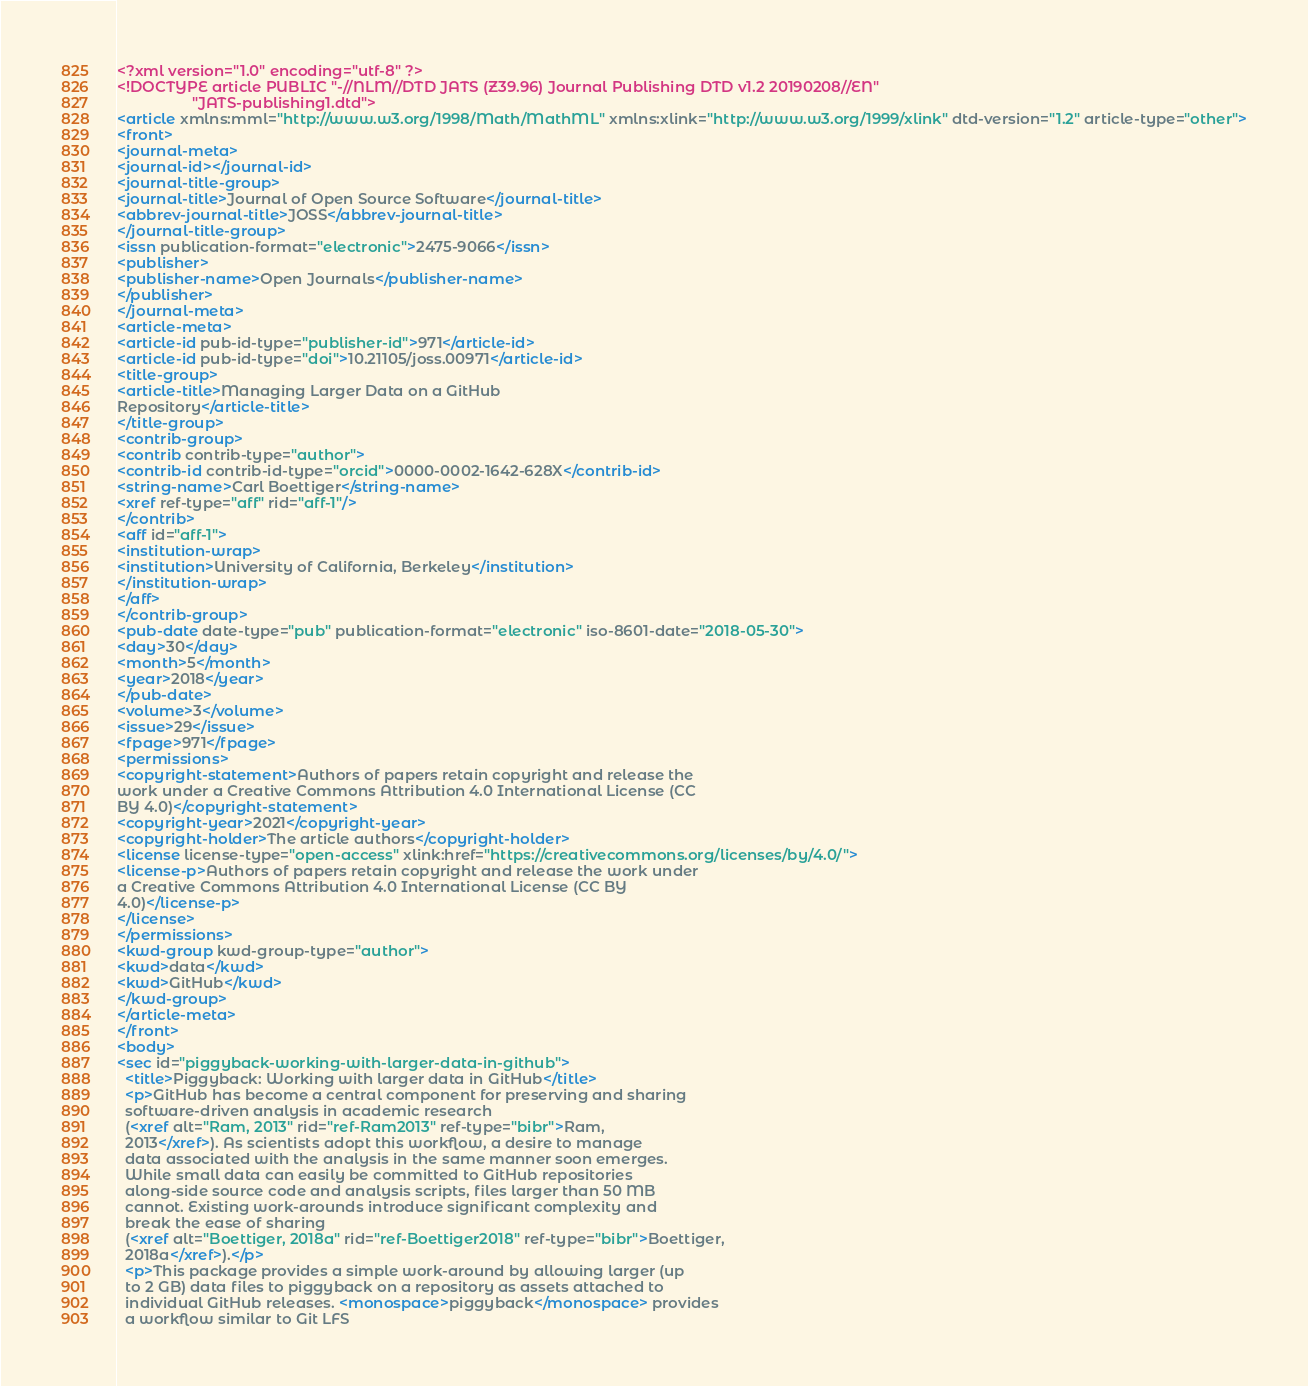Convert code to text. <code><loc_0><loc_0><loc_500><loc_500><_XML_><?xml version="1.0" encoding="utf-8" ?>
<!DOCTYPE article PUBLIC "-//NLM//DTD JATS (Z39.96) Journal Publishing DTD v1.2 20190208//EN"
                  "JATS-publishing1.dtd">
<article xmlns:mml="http://www.w3.org/1998/Math/MathML" xmlns:xlink="http://www.w3.org/1999/xlink" dtd-version="1.2" article-type="other">
<front>
<journal-meta>
<journal-id></journal-id>
<journal-title-group>
<journal-title>Journal of Open Source Software</journal-title>
<abbrev-journal-title>JOSS</abbrev-journal-title>
</journal-title-group>
<issn publication-format="electronic">2475-9066</issn>
<publisher>
<publisher-name>Open Journals</publisher-name>
</publisher>
</journal-meta>
<article-meta>
<article-id pub-id-type="publisher-id">971</article-id>
<article-id pub-id-type="doi">10.21105/joss.00971</article-id>
<title-group>
<article-title>Managing Larger Data on a GitHub
Repository</article-title>
</title-group>
<contrib-group>
<contrib contrib-type="author">
<contrib-id contrib-id-type="orcid">0000-0002-1642-628X</contrib-id>
<string-name>Carl Boettiger</string-name>
<xref ref-type="aff" rid="aff-1"/>
</contrib>
<aff id="aff-1">
<institution-wrap>
<institution>University of California, Berkeley</institution>
</institution-wrap>
</aff>
</contrib-group>
<pub-date date-type="pub" publication-format="electronic" iso-8601-date="2018-05-30">
<day>30</day>
<month>5</month>
<year>2018</year>
</pub-date>
<volume>3</volume>
<issue>29</issue>
<fpage>971</fpage>
<permissions>
<copyright-statement>Authors of papers retain copyright and release the
work under a Creative Commons Attribution 4.0 International License (CC
BY 4.0)</copyright-statement>
<copyright-year>2021</copyright-year>
<copyright-holder>The article authors</copyright-holder>
<license license-type="open-access" xlink:href="https://creativecommons.org/licenses/by/4.0/">
<license-p>Authors of papers retain copyright and release the work under
a Creative Commons Attribution 4.0 International License (CC BY
4.0)</license-p>
</license>
</permissions>
<kwd-group kwd-group-type="author">
<kwd>data</kwd>
<kwd>GitHub</kwd>
</kwd-group>
</article-meta>
</front>
<body>
<sec id="piggyback-working-with-larger-data-in-github">
  <title>Piggyback: Working with larger data in GitHub</title>
  <p>GitHub has become a central component for preserving and sharing
  software-driven analysis in academic research
  (<xref alt="Ram, 2013" rid="ref-Ram2013" ref-type="bibr">Ram,
  2013</xref>). As scientists adopt this workflow, a desire to manage
  data associated with the analysis in the same manner soon emerges.
  While small data can easily be committed to GitHub repositories
  along-side source code and analysis scripts, files larger than 50 MB
  cannot. Existing work-arounds introduce significant complexity and
  break the ease of sharing
  (<xref alt="Boettiger, 2018a" rid="ref-Boettiger2018" ref-type="bibr">Boettiger,
  2018a</xref>).</p>
  <p>This package provides a simple work-around by allowing larger (up
  to 2 GB) data files to piggyback on a repository as assets attached to
  individual GitHub releases. <monospace>piggyback</monospace> provides
  a workflow similar to Git LFS</code> 